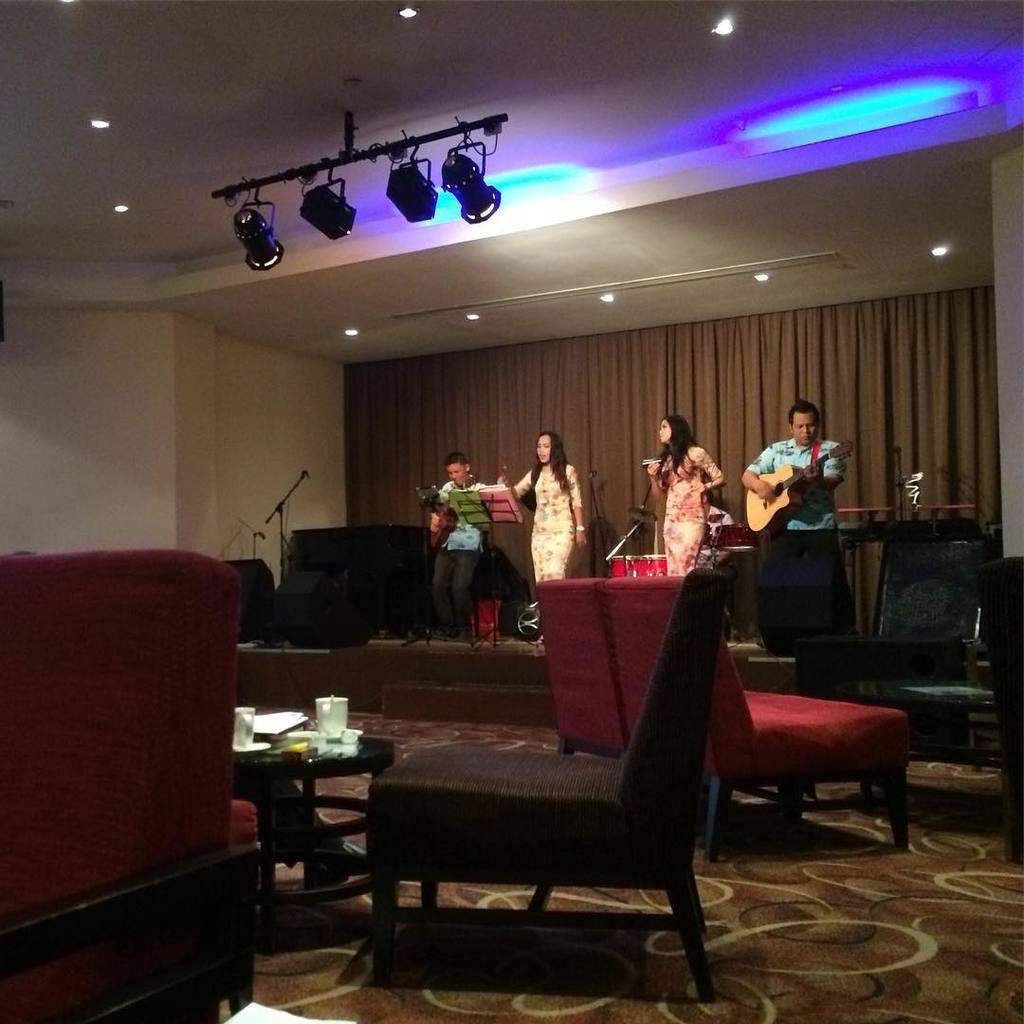What type of space is shown in the image? The image depicts a room. What furniture is present in the room? There are chairs and a table in the room. Are there any objects on the table? Yes, there are items on the table. What is happening on stage in the image? There are four people on stage, and they are playing musical instruments. How many drawers are visible in the image? There are no drawers visible in the image. Can you see an airplane in the image? No, there is no airplane present in the image. 